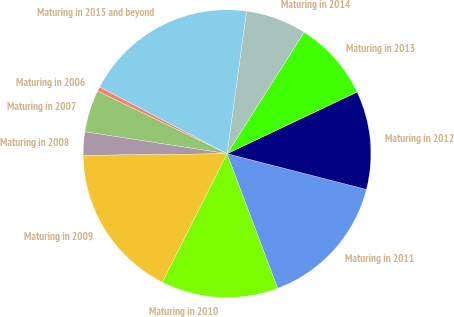Convert chart. <chart><loc_0><loc_0><loc_500><loc_500><pie_chart><fcel>Maturing in 2006<fcel>Maturing in 2007<fcel>Maturing in 2008<fcel>Maturing in 2009<fcel>Maturing in 2010<fcel>Maturing in 2011<fcel>Maturing in 2012<fcel>Maturing in 2013<fcel>Maturing in 2014<fcel>Maturing in 2015 and beyond<nl><fcel>0.52%<fcel>4.73%<fcel>2.62%<fcel>17.38%<fcel>13.16%<fcel>15.27%<fcel>11.05%<fcel>8.95%<fcel>6.84%<fcel>19.48%<nl></chart> 